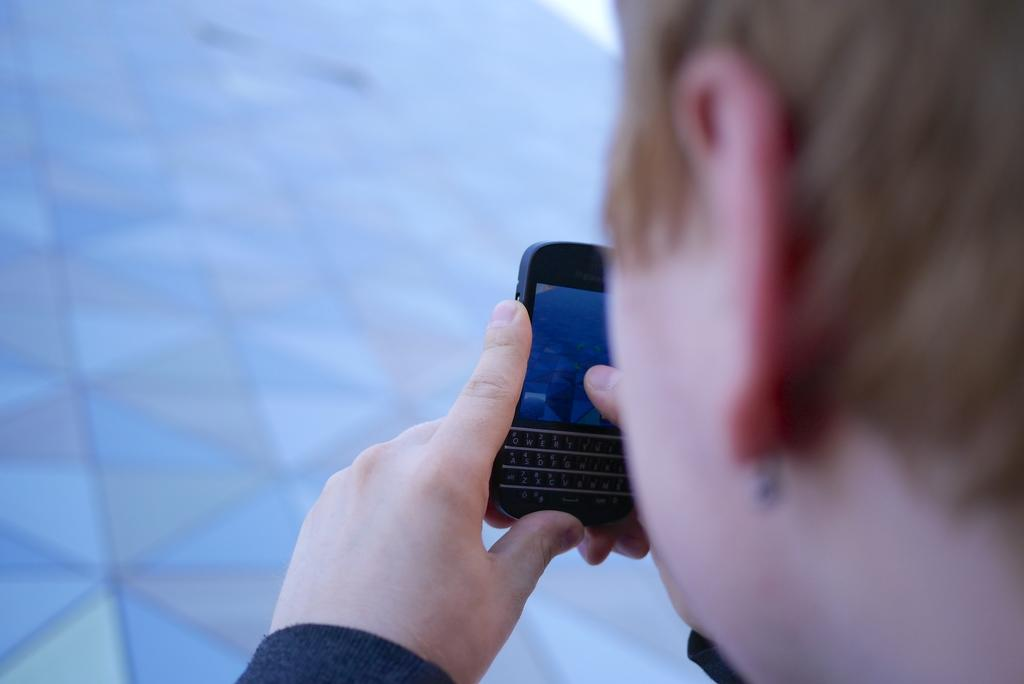Who is present in the image? There is a person in the image. What is the person holding in the image? The person is holding a mobile phone. Where is the person located in the image? The person is on a street. How many dogs are digging a hole in the image? There are no dogs or holes present in the image. 